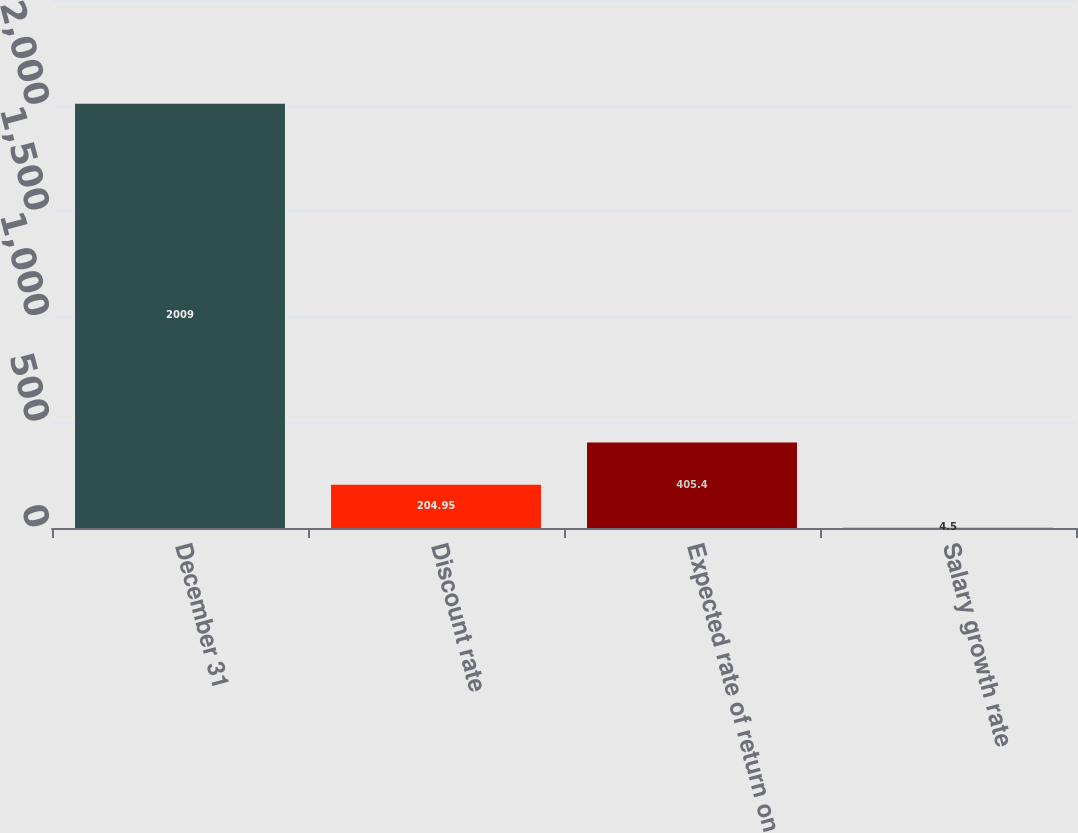Convert chart. <chart><loc_0><loc_0><loc_500><loc_500><bar_chart><fcel>December 31<fcel>Discount rate<fcel>Expected rate of return on<fcel>Salary growth rate<nl><fcel>2009<fcel>204.95<fcel>405.4<fcel>4.5<nl></chart> 